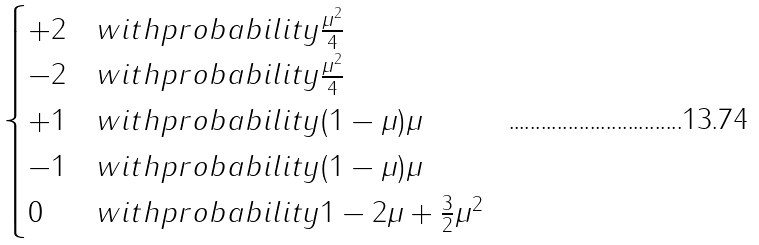<formula> <loc_0><loc_0><loc_500><loc_500>\begin{cases} + 2 & w i t h p r o b a b i l i t y \frac { \mu ^ { 2 } } { 4 } \\ - 2 & w i t h p r o b a b i l i t y \frac { \mu ^ { 2 } } { 4 } \\ + 1 & w i t h p r o b a b i l i t y ( 1 - \mu ) \mu \\ - 1 & w i t h p r o b a b i l i t y ( 1 - \mu ) \mu \\ 0 & w i t h p r o b a b i l i t y 1 - 2 \mu + \frac { 3 } { 2 } \mu ^ { 2 } \end{cases}</formula> 